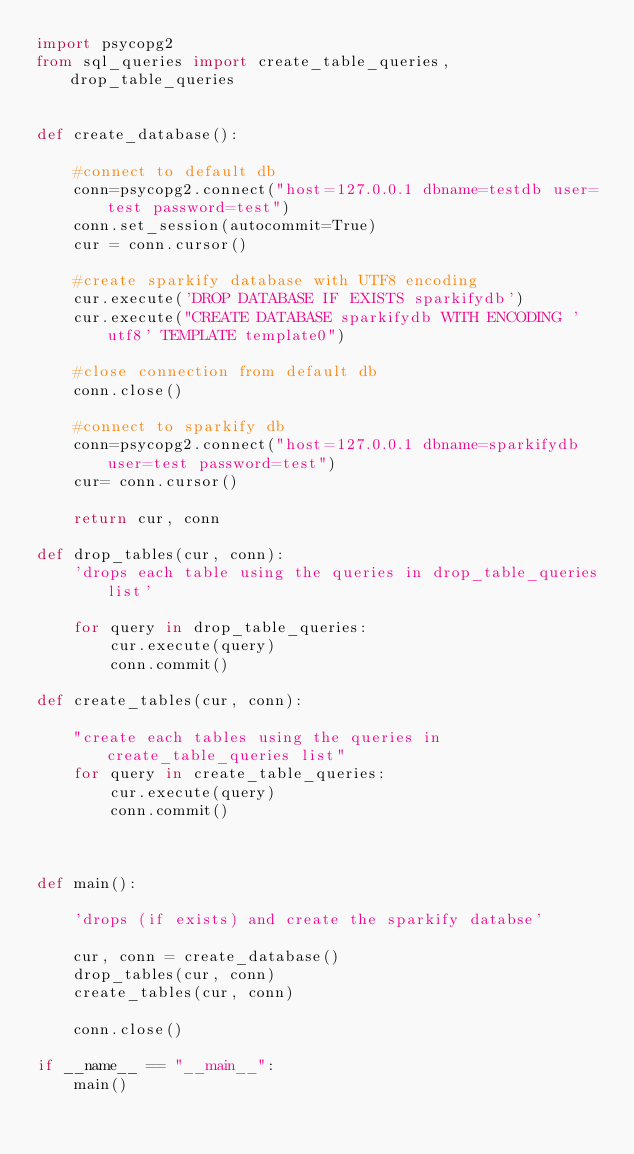Convert code to text. <code><loc_0><loc_0><loc_500><loc_500><_Python_>import psycopg2
from sql_queries import create_table_queries, drop_table_queries


def create_database():

    #connect to default db
    conn=psycopg2.connect("host=127.0.0.1 dbname=testdb user=test password=test")
    conn.set_session(autocommit=True)
    cur = conn.cursor()
    
    #create sparkify database with UTF8 encoding
    cur.execute('DROP DATABASE IF EXISTS sparkifydb')
    cur.execute("CREATE DATABASE sparkifydb WITH ENCODING 'utf8' TEMPLATE template0")

    #close connection from default db
    conn.close()

    #connect to sparkify db
    conn=psycopg2.connect("host=127.0.0.1 dbname=sparkifydb user=test password=test")
    cur= conn.cursor()

    return cur, conn

def drop_tables(cur, conn):
    'drops each table using the queries in drop_table_queries list'

    for query in drop_table_queries:
        cur.execute(query)
        conn.commit()

def create_tables(cur, conn):

    "create each tables using the queries in create_table_queries list"
    for query in create_table_queries:
        cur.execute(query)
        conn.commit()



def main():

    'drops (if exists) and create the sparkify databse'

    cur, conn = create_database()
    drop_tables(cur, conn)
    create_tables(cur, conn)
    
    conn.close()

if __name__ == "__main__":
    main()
</code> 